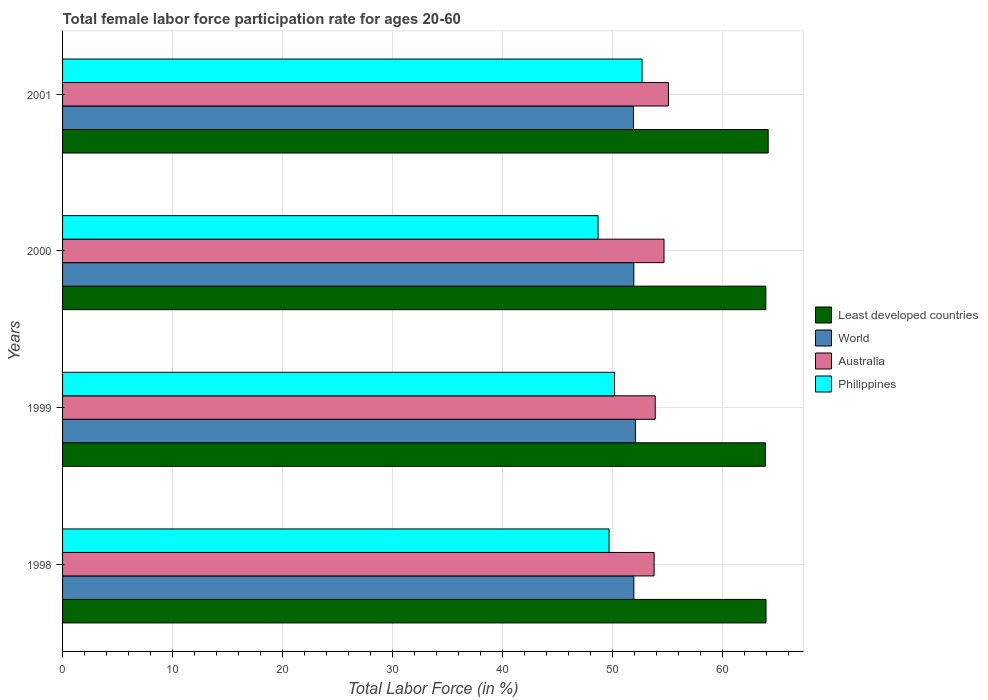How many groups of bars are there?
Ensure brevity in your answer.  4. What is the female labor force participation rate in Least developed countries in 1998?
Provide a short and direct response. 63.98. Across all years, what is the maximum female labor force participation rate in World?
Keep it short and to the point. 52.1. Across all years, what is the minimum female labor force participation rate in Least developed countries?
Offer a terse response. 63.92. In which year was the female labor force participation rate in Least developed countries minimum?
Give a very brief answer. 1999. What is the total female labor force participation rate in Least developed countries in the graph?
Your answer should be very brief. 256.03. What is the difference between the female labor force participation rate in World in 1998 and that in 1999?
Make the answer very short. -0.14. What is the difference between the female labor force participation rate in Australia in 1998 and the female labor force participation rate in Least developed countries in 1999?
Your answer should be compact. -10.12. What is the average female labor force participation rate in Least developed countries per year?
Your answer should be compact. 64.01. In the year 1998, what is the difference between the female labor force participation rate in World and female labor force participation rate in Least developed countries?
Provide a short and direct response. -12.02. In how many years, is the female labor force participation rate in Philippines greater than 30 %?
Your answer should be compact. 4. What is the ratio of the female labor force participation rate in Australia in 1998 to that in 2001?
Offer a terse response. 0.98. What is the difference between the highest and the second highest female labor force participation rate in Least developed countries?
Give a very brief answer. 0.2. What is the difference between the highest and the lowest female labor force participation rate in Philippines?
Your response must be concise. 4. Is the sum of the female labor force participation rate in World in 2000 and 2001 greater than the maximum female labor force participation rate in Australia across all years?
Offer a terse response. Yes. What does the 4th bar from the top in 2000 represents?
Ensure brevity in your answer.  Least developed countries. Is it the case that in every year, the sum of the female labor force participation rate in World and female labor force participation rate in Australia is greater than the female labor force participation rate in Least developed countries?
Your response must be concise. Yes. How many bars are there?
Your response must be concise. 16. Are all the bars in the graph horizontal?
Provide a succinct answer. Yes. Does the graph contain grids?
Your response must be concise. Yes. How many legend labels are there?
Give a very brief answer. 4. How are the legend labels stacked?
Ensure brevity in your answer.  Vertical. What is the title of the graph?
Offer a terse response. Total female labor force participation rate for ages 20-60. Does "Aruba" appear as one of the legend labels in the graph?
Make the answer very short. No. What is the label or title of the X-axis?
Your answer should be very brief. Total Labor Force (in %). What is the Total Labor Force (in %) of Least developed countries in 1998?
Your response must be concise. 63.98. What is the Total Labor Force (in %) in World in 1998?
Provide a short and direct response. 51.95. What is the Total Labor Force (in %) in Australia in 1998?
Provide a short and direct response. 53.8. What is the Total Labor Force (in %) of Philippines in 1998?
Your answer should be compact. 49.7. What is the Total Labor Force (in %) of Least developed countries in 1999?
Offer a terse response. 63.92. What is the Total Labor Force (in %) of World in 1999?
Give a very brief answer. 52.1. What is the Total Labor Force (in %) in Australia in 1999?
Provide a short and direct response. 53.9. What is the Total Labor Force (in %) in Philippines in 1999?
Your response must be concise. 50.2. What is the Total Labor Force (in %) of Least developed countries in 2000?
Offer a terse response. 63.96. What is the Total Labor Force (in %) in World in 2000?
Offer a terse response. 51.95. What is the Total Labor Force (in %) in Australia in 2000?
Provide a succinct answer. 54.7. What is the Total Labor Force (in %) in Philippines in 2000?
Your answer should be very brief. 48.7. What is the Total Labor Force (in %) in Least developed countries in 2001?
Provide a succinct answer. 64.17. What is the Total Labor Force (in %) in World in 2001?
Your answer should be very brief. 51.92. What is the Total Labor Force (in %) in Australia in 2001?
Give a very brief answer. 55.1. What is the Total Labor Force (in %) in Philippines in 2001?
Your answer should be very brief. 52.7. Across all years, what is the maximum Total Labor Force (in %) of Least developed countries?
Your answer should be very brief. 64.17. Across all years, what is the maximum Total Labor Force (in %) in World?
Give a very brief answer. 52.1. Across all years, what is the maximum Total Labor Force (in %) of Australia?
Your answer should be compact. 55.1. Across all years, what is the maximum Total Labor Force (in %) of Philippines?
Your response must be concise. 52.7. Across all years, what is the minimum Total Labor Force (in %) in Least developed countries?
Your response must be concise. 63.92. Across all years, what is the minimum Total Labor Force (in %) of World?
Ensure brevity in your answer.  51.92. Across all years, what is the minimum Total Labor Force (in %) in Australia?
Ensure brevity in your answer.  53.8. Across all years, what is the minimum Total Labor Force (in %) in Philippines?
Keep it short and to the point. 48.7. What is the total Total Labor Force (in %) in Least developed countries in the graph?
Your response must be concise. 256.03. What is the total Total Labor Force (in %) in World in the graph?
Provide a succinct answer. 207.93. What is the total Total Labor Force (in %) in Australia in the graph?
Your response must be concise. 217.5. What is the total Total Labor Force (in %) in Philippines in the graph?
Keep it short and to the point. 201.3. What is the difference between the Total Labor Force (in %) of Least developed countries in 1998 and that in 1999?
Ensure brevity in your answer.  0.06. What is the difference between the Total Labor Force (in %) of World in 1998 and that in 1999?
Offer a terse response. -0.14. What is the difference between the Total Labor Force (in %) of Philippines in 1998 and that in 1999?
Make the answer very short. -0.5. What is the difference between the Total Labor Force (in %) in Least developed countries in 1998 and that in 2000?
Your answer should be very brief. 0.02. What is the difference between the Total Labor Force (in %) of World in 1998 and that in 2000?
Give a very brief answer. 0. What is the difference between the Total Labor Force (in %) in Least developed countries in 1998 and that in 2001?
Your answer should be compact. -0.2. What is the difference between the Total Labor Force (in %) in World in 1998 and that in 2001?
Your answer should be very brief. 0.03. What is the difference between the Total Labor Force (in %) of Philippines in 1998 and that in 2001?
Your answer should be very brief. -3. What is the difference between the Total Labor Force (in %) in Least developed countries in 1999 and that in 2000?
Keep it short and to the point. -0.04. What is the difference between the Total Labor Force (in %) of World in 1999 and that in 2000?
Make the answer very short. 0.15. What is the difference between the Total Labor Force (in %) in Philippines in 1999 and that in 2000?
Ensure brevity in your answer.  1.5. What is the difference between the Total Labor Force (in %) in Least developed countries in 1999 and that in 2001?
Provide a succinct answer. -0.25. What is the difference between the Total Labor Force (in %) of World in 1999 and that in 2001?
Keep it short and to the point. 0.17. What is the difference between the Total Labor Force (in %) in Least developed countries in 2000 and that in 2001?
Offer a very short reply. -0.21. What is the difference between the Total Labor Force (in %) in World in 2000 and that in 2001?
Offer a terse response. 0.03. What is the difference between the Total Labor Force (in %) in Least developed countries in 1998 and the Total Labor Force (in %) in World in 1999?
Keep it short and to the point. 11.88. What is the difference between the Total Labor Force (in %) of Least developed countries in 1998 and the Total Labor Force (in %) of Australia in 1999?
Your answer should be very brief. 10.08. What is the difference between the Total Labor Force (in %) of Least developed countries in 1998 and the Total Labor Force (in %) of Philippines in 1999?
Offer a terse response. 13.78. What is the difference between the Total Labor Force (in %) in World in 1998 and the Total Labor Force (in %) in Australia in 1999?
Offer a terse response. -1.95. What is the difference between the Total Labor Force (in %) in World in 1998 and the Total Labor Force (in %) in Philippines in 1999?
Your answer should be very brief. 1.75. What is the difference between the Total Labor Force (in %) in Least developed countries in 1998 and the Total Labor Force (in %) in World in 2000?
Offer a terse response. 12.03. What is the difference between the Total Labor Force (in %) of Least developed countries in 1998 and the Total Labor Force (in %) of Australia in 2000?
Offer a very short reply. 9.28. What is the difference between the Total Labor Force (in %) in Least developed countries in 1998 and the Total Labor Force (in %) in Philippines in 2000?
Make the answer very short. 15.28. What is the difference between the Total Labor Force (in %) in World in 1998 and the Total Labor Force (in %) in Australia in 2000?
Your answer should be compact. -2.75. What is the difference between the Total Labor Force (in %) of World in 1998 and the Total Labor Force (in %) of Philippines in 2000?
Provide a succinct answer. 3.25. What is the difference between the Total Labor Force (in %) of Australia in 1998 and the Total Labor Force (in %) of Philippines in 2000?
Provide a short and direct response. 5.1. What is the difference between the Total Labor Force (in %) in Least developed countries in 1998 and the Total Labor Force (in %) in World in 2001?
Your response must be concise. 12.05. What is the difference between the Total Labor Force (in %) of Least developed countries in 1998 and the Total Labor Force (in %) of Australia in 2001?
Keep it short and to the point. 8.88. What is the difference between the Total Labor Force (in %) in Least developed countries in 1998 and the Total Labor Force (in %) in Philippines in 2001?
Give a very brief answer. 11.28. What is the difference between the Total Labor Force (in %) of World in 1998 and the Total Labor Force (in %) of Australia in 2001?
Offer a terse response. -3.15. What is the difference between the Total Labor Force (in %) of World in 1998 and the Total Labor Force (in %) of Philippines in 2001?
Ensure brevity in your answer.  -0.75. What is the difference between the Total Labor Force (in %) of Australia in 1998 and the Total Labor Force (in %) of Philippines in 2001?
Provide a short and direct response. 1.1. What is the difference between the Total Labor Force (in %) in Least developed countries in 1999 and the Total Labor Force (in %) in World in 2000?
Your answer should be compact. 11.97. What is the difference between the Total Labor Force (in %) of Least developed countries in 1999 and the Total Labor Force (in %) of Australia in 2000?
Offer a terse response. 9.22. What is the difference between the Total Labor Force (in %) in Least developed countries in 1999 and the Total Labor Force (in %) in Philippines in 2000?
Make the answer very short. 15.22. What is the difference between the Total Labor Force (in %) in World in 1999 and the Total Labor Force (in %) in Australia in 2000?
Ensure brevity in your answer.  -2.6. What is the difference between the Total Labor Force (in %) of World in 1999 and the Total Labor Force (in %) of Philippines in 2000?
Ensure brevity in your answer.  3.4. What is the difference between the Total Labor Force (in %) in Australia in 1999 and the Total Labor Force (in %) in Philippines in 2000?
Give a very brief answer. 5.2. What is the difference between the Total Labor Force (in %) in Least developed countries in 1999 and the Total Labor Force (in %) in World in 2001?
Make the answer very short. 12. What is the difference between the Total Labor Force (in %) of Least developed countries in 1999 and the Total Labor Force (in %) of Australia in 2001?
Provide a succinct answer. 8.82. What is the difference between the Total Labor Force (in %) in Least developed countries in 1999 and the Total Labor Force (in %) in Philippines in 2001?
Your response must be concise. 11.22. What is the difference between the Total Labor Force (in %) in World in 1999 and the Total Labor Force (in %) in Australia in 2001?
Provide a short and direct response. -3. What is the difference between the Total Labor Force (in %) in World in 1999 and the Total Labor Force (in %) in Philippines in 2001?
Keep it short and to the point. -0.6. What is the difference between the Total Labor Force (in %) in Australia in 1999 and the Total Labor Force (in %) in Philippines in 2001?
Offer a very short reply. 1.2. What is the difference between the Total Labor Force (in %) of Least developed countries in 2000 and the Total Labor Force (in %) of World in 2001?
Ensure brevity in your answer.  12.04. What is the difference between the Total Labor Force (in %) in Least developed countries in 2000 and the Total Labor Force (in %) in Australia in 2001?
Keep it short and to the point. 8.86. What is the difference between the Total Labor Force (in %) in Least developed countries in 2000 and the Total Labor Force (in %) in Philippines in 2001?
Give a very brief answer. 11.26. What is the difference between the Total Labor Force (in %) of World in 2000 and the Total Labor Force (in %) of Australia in 2001?
Provide a succinct answer. -3.15. What is the difference between the Total Labor Force (in %) in World in 2000 and the Total Labor Force (in %) in Philippines in 2001?
Keep it short and to the point. -0.75. What is the average Total Labor Force (in %) in Least developed countries per year?
Ensure brevity in your answer.  64.01. What is the average Total Labor Force (in %) of World per year?
Offer a very short reply. 51.98. What is the average Total Labor Force (in %) of Australia per year?
Provide a short and direct response. 54.38. What is the average Total Labor Force (in %) of Philippines per year?
Offer a terse response. 50.33. In the year 1998, what is the difference between the Total Labor Force (in %) in Least developed countries and Total Labor Force (in %) in World?
Ensure brevity in your answer.  12.02. In the year 1998, what is the difference between the Total Labor Force (in %) in Least developed countries and Total Labor Force (in %) in Australia?
Provide a succinct answer. 10.18. In the year 1998, what is the difference between the Total Labor Force (in %) in Least developed countries and Total Labor Force (in %) in Philippines?
Provide a short and direct response. 14.28. In the year 1998, what is the difference between the Total Labor Force (in %) in World and Total Labor Force (in %) in Australia?
Ensure brevity in your answer.  -1.85. In the year 1998, what is the difference between the Total Labor Force (in %) of World and Total Labor Force (in %) of Philippines?
Make the answer very short. 2.25. In the year 1999, what is the difference between the Total Labor Force (in %) in Least developed countries and Total Labor Force (in %) in World?
Keep it short and to the point. 11.82. In the year 1999, what is the difference between the Total Labor Force (in %) in Least developed countries and Total Labor Force (in %) in Australia?
Keep it short and to the point. 10.02. In the year 1999, what is the difference between the Total Labor Force (in %) in Least developed countries and Total Labor Force (in %) in Philippines?
Give a very brief answer. 13.72. In the year 1999, what is the difference between the Total Labor Force (in %) in World and Total Labor Force (in %) in Australia?
Make the answer very short. -1.8. In the year 1999, what is the difference between the Total Labor Force (in %) in World and Total Labor Force (in %) in Philippines?
Keep it short and to the point. 1.9. In the year 2000, what is the difference between the Total Labor Force (in %) in Least developed countries and Total Labor Force (in %) in World?
Keep it short and to the point. 12.01. In the year 2000, what is the difference between the Total Labor Force (in %) of Least developed countries and Total Labor Force (in %) of Australia?
Give a very brief answer. 9.26. In the year 2000, what is the difference between the Total Labor Force (in %) in Least developed countries and Total Labor Force (in %) in Philippines?
Keep it short and to the point. 15.26. In the year 2000, what is the difference between the Total Labor Force (in %) of World and Total Labor Force (in %) of Australia?
Make the answer very short. -2.75. In the year 2000, what is the difference between the Total Labor Force (in %) in World and Total Labor Force (in %) in Philippines?
Ensure brevity in your answer.  3.25. In the year 2001, what is the difference between the Total Labor Force (in %) of Least developed countries and Total Labor Force (in %) of World?
Make the answer very short. 12.25. In the year 2001, what is the difference between the Total Labor Force (in %) in Least developed countries and Total Labor Force (in %) in Australia?
Keep it short and to the point. 9.07. In the year 2001, what is the difference between the Total Labor Force (in %) in Least developed countries and Total Labor Force (in %) in Philippines?
Make the answer very short. 11.47. In the year 2001, what is the difference between the Total Labor Force (in %) of World and Total Labor Force (in %) of Australia?
Offer a very short reply. -3.18. In the year 2001, what is the difference between the Total Labor Force (in %) of World and Total Labor Force (in %) of Philippines?
Make the answer very short. -0.78. In the year 2001, what is the difference between the Total Labor Force (in %) of Australia and Total Labor Force (in %) of Philippines?
Ensure brevity in your answer.  2.4. What is the ratio of the Total Labor Force (in %) of Least developed countries in 1998 to that in 1999?
Offer a very short reply. 1. What is the ratio of the Total Labor Force (in %) of World in 1998 to that in 1999?
Offer a very short reply. 1. What is the ratio of the Total Labor Force (in %) in World in 1998 to that in 2000?
Offer a terse response. 1. What is the ratio of the Total Labor Force (in %) in Australia in 1998 to that in 2000?
Keep it short and to the point. 0.98. What is the ratio of the Total Labor Force (in %) in Philippines in 1998 to that in 2000?
Offer a very short reply. 1.02. What is the ratio of the Total Labor Force (in %) in World in 1998 to that in 2001?
Your answer should be very brief. 1. What is the ratio of the Total Labor Force (in %) in Australia in 1998 to that in 2001?
Your answer should be very brief. 0.98. What is the ratio of the Total Labor Force (in %) of Philippines in 1998 to that in 2001?
Make the answer very short. 0.94. What is the ratio of the Total Labor Force (in %) of Least developed countries in 1999 to that in 2000?
Your answer should be compact. 1. What is the ratio of the Total Labor Force (in %) of World in 1999 to that in 2000?
Your answer should be compact. 1. What is the ratio of the Total Labor Force (in %) of Australia in 1999 to that in 2000?
Keep it short and to the point. 0.99. What is the ratio of the Total Labor Force (in %) in Philippines in 1999 to that in 2000?
Offer a very short reply. 1.03. What is the ratio of the Total Labor Force (in %) in Least developed countries in 1999 to that in 2001?
Offer a very short reply. 1. What is the ratio of the Total Labor Force (in %) in Australia in 1999 to that in 2001?
Offer a very short reply. 0.98. What is the ratio of the Total Labor Force (in %) in Philippines in 1999 to that in 2001?
Give a very brief answer. 0.95. What is the ratio of the Total Labor Force (in %) of Least developed countries in 2000 to that in 2001?
Offer a very short reply. 1. What is the ratio of the Total Labor Force (in %) of World in 2000 to that in 2001?
Make the answer very short. 1. What is the ratio of the Total Labor Force (in %) in Australia in 2000 to that in 2001?
Your answer should be very brief. 0.99. What is the ratio of the Total Labor Force (in %) of Philippines in 2000 to that in 2001?
Give a very brief answer. 0.92. What is the difference between the highest and the second highest Total Labor Force (in %) of Least developed countries?
Keep it short and to the point. 0.2. What is the difference between the highest and the second highest Total Labor Force (in %) in World?
Make the answer very short. 0.14. What is the difference between the highest and the second highest Total Labor Force (in %) in Australia?
Make the answer very short. 0.4. What is the difference between the highest and the lowest Total Labor Force (in %) in Least developed countries?
Give a very brief answer. 0.25. What is the difference between the highest and the lowest Total Labor Force (in %) in World?
Give a very brief answer. 0.17. What is the difference between the highest and the lowest Total Labor Force (in %) in Australia?
Ensure brevity in your answer.  1.3. 